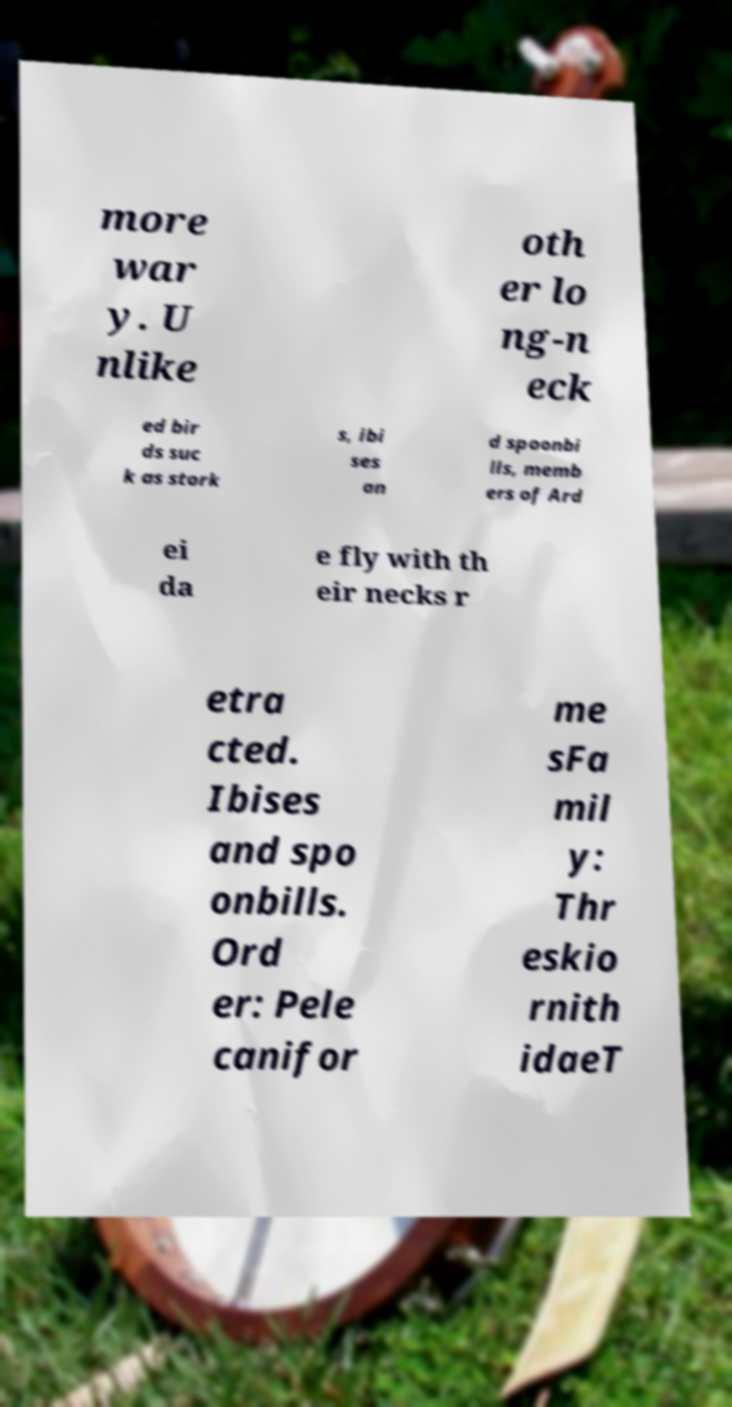Can you read and provide the text displayed in the image?This photo seems to have some interesting text. Can you extract and type it out for me? more war y. U nlike oth er lo ng-n eck ed bir ds suc k as stork s, ibi ses an d spoonbi lls, memb ers of Ard ei da e fly with th eir necks r etra cted. Ibises and spo onbills. Ord er: Pele canifor me sFa mil y: Thr eskio rnith idaeT 